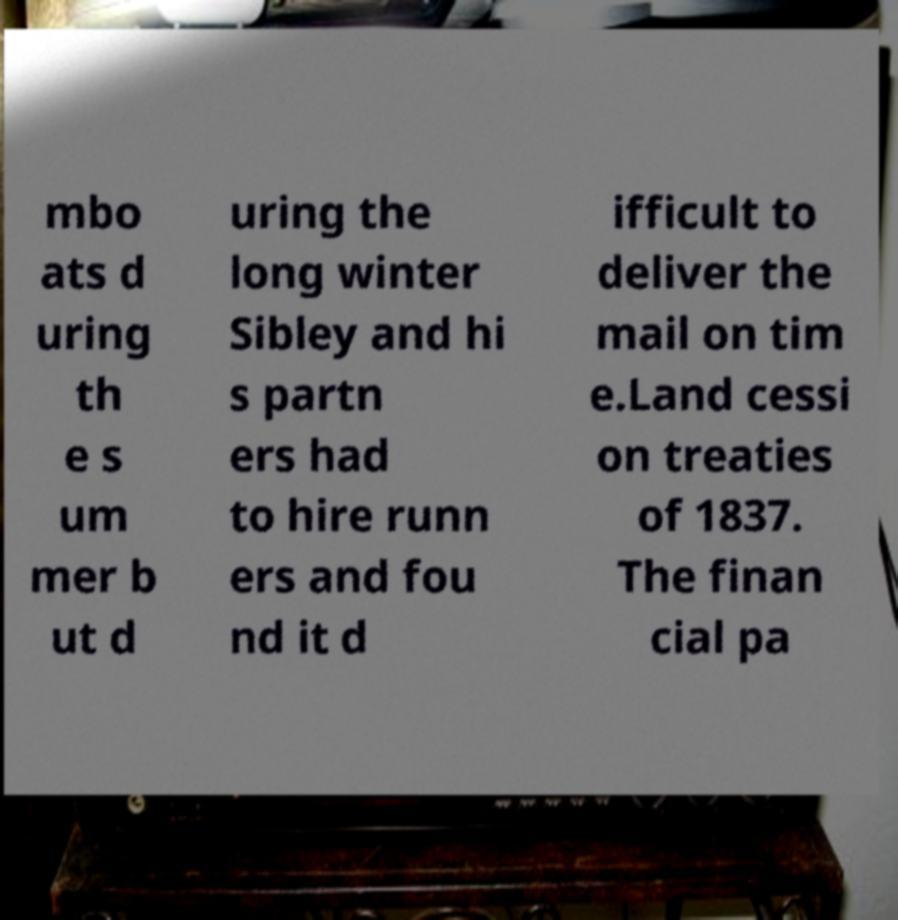What messages or text are displayed in this image? I need them in a readable, typed format. mbo ats d uring th e s um mer b ut d uring the long winter Sibley and hi s partn ers had to hire runn ers and fou nd it d ifficult to deliver the mail on tim e.Land cessi on treaties of 1837. The finan cial pa 